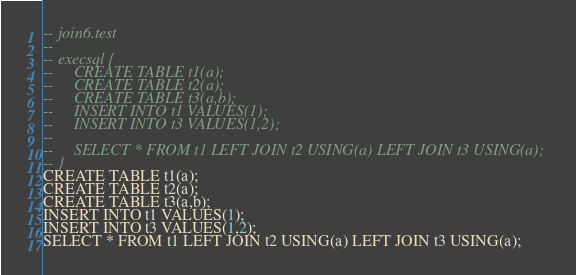<code> <loc_0><loc_0><loc_500><loc_500><_SQL_>-- join6.test
-- 
-- execsql {
--     CREATE TABLE t1(a);
--     CREATE TABLE t2(a);
--     CREATE TABLE t3(a,b);
--     INSERT INTO t1 VALUES(1);
--     INSERT INTO t3 VALUES(1,2);
-- 
--     SELECT * FROM t1 LEFT JOIN t2 USING(a) LEFT JOIN t3 USING(a);
-- }
CREATE TABLE t1(a);
CREATE TABLE t2(a);
CREATE TABLE t3(a,b);
INSERT INTO t1 VALUES(1);
INSERT INTO t3 VALUES(1,2);
SELECT * FROM t1 LEFT JOIN t2 USING(a) LEFT JOIN t3 USING(a);</code> 